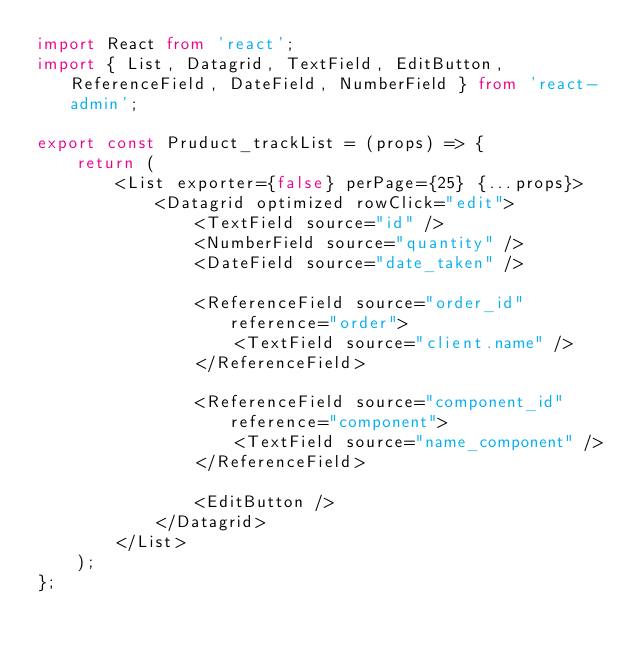<code> <loc_0><loc_0><loc_500><loc_500><_TypeScript_>import React from 'react';
import { List, Datagrid, TextField, EditButton, ReferenceField, DateField, NumberField } from 'react-admin';

export const Pruduct_trackList = (props) => {
    return (
        <List exporter={false} perPage={25} {...props}>
            <Datagrid optimized rowClick="edit">
                <TextField source="id" />
                <NumberField source="quantity" />
                <DateField source="date_taken" />

                <ReferenceField source="order_id" reference="order">
                    <TextField source="client.name" />
                </ReferenceField>

                <ReferenceField source="component_id" reference="component">
                    <TextField source="name_component" />
                </ReferenceField>

                <EditButton />
            </Datagrid>
        </List>
    );
};
</code> 